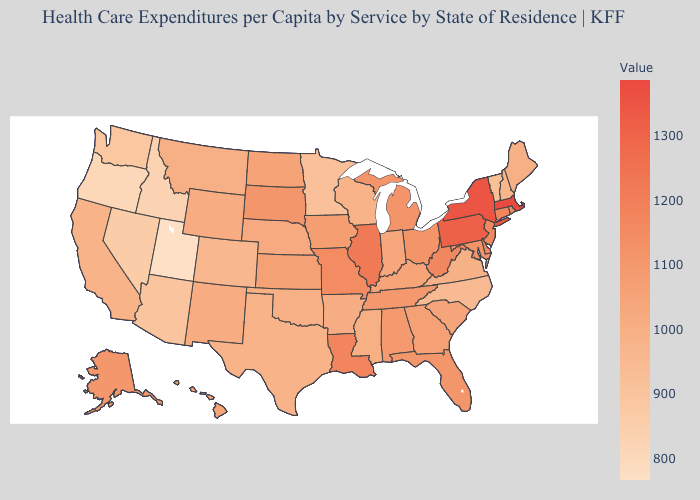Which states have the lowest value in the USA?
Write a very short answer. Utah. Does New Hampshire have the highest value in the Northeast?
Answer briefly. No. Is the legend a continuous bar?
Be succinct. Yes. Is the legend a continuous bar?
Give a very brief answer. Yes. Does West Virginia have the lowest value in the South?
Give a very brief answer. No. Does Massachusetts have the highest value in the USA?
Write a very short answer. Yes. Among the states that border Kentucky , which have the lowest value?
Be succinct. Virginia. Is the legend a continuous bar?
Answer briefly. Yes. Does Iowa have the highest value in the USA?
Concise answer only. No. 